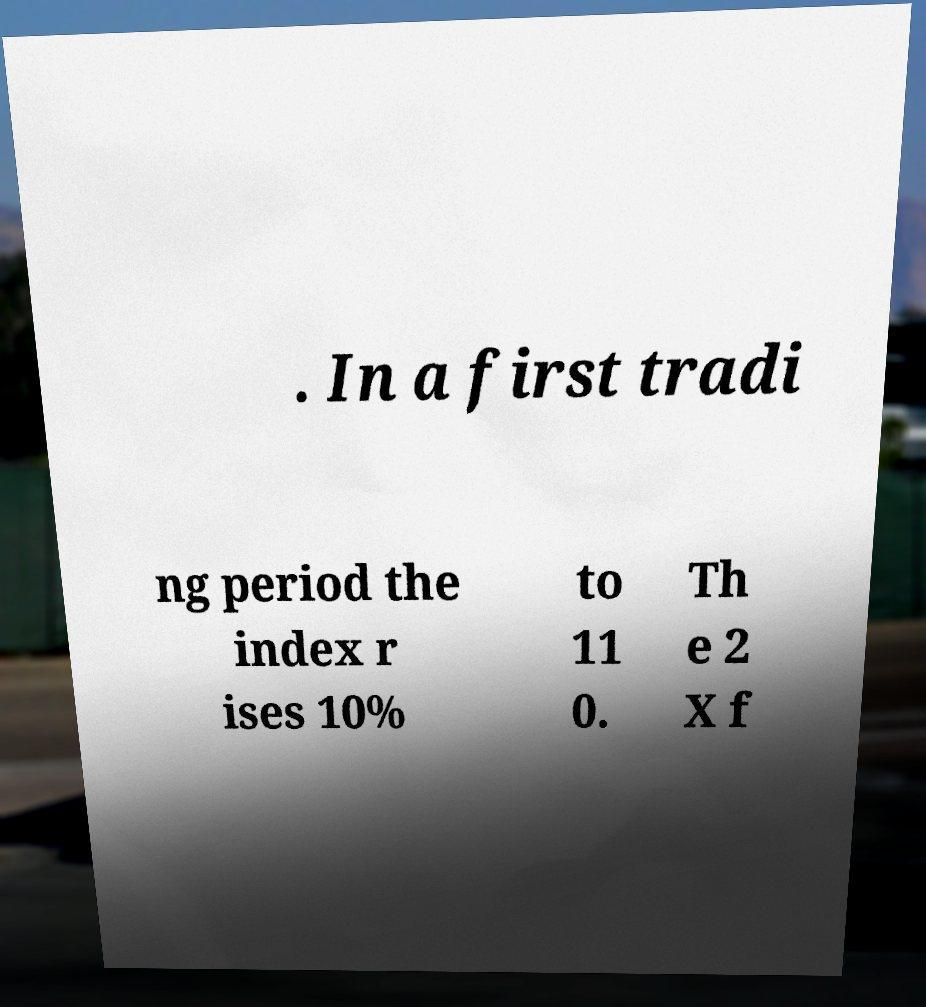For documentation purposes, I need the text within this image transcribed. Could you provide that? . In a first tradi ng period the index r ises 10% to 11 0. Th e 2 X f 